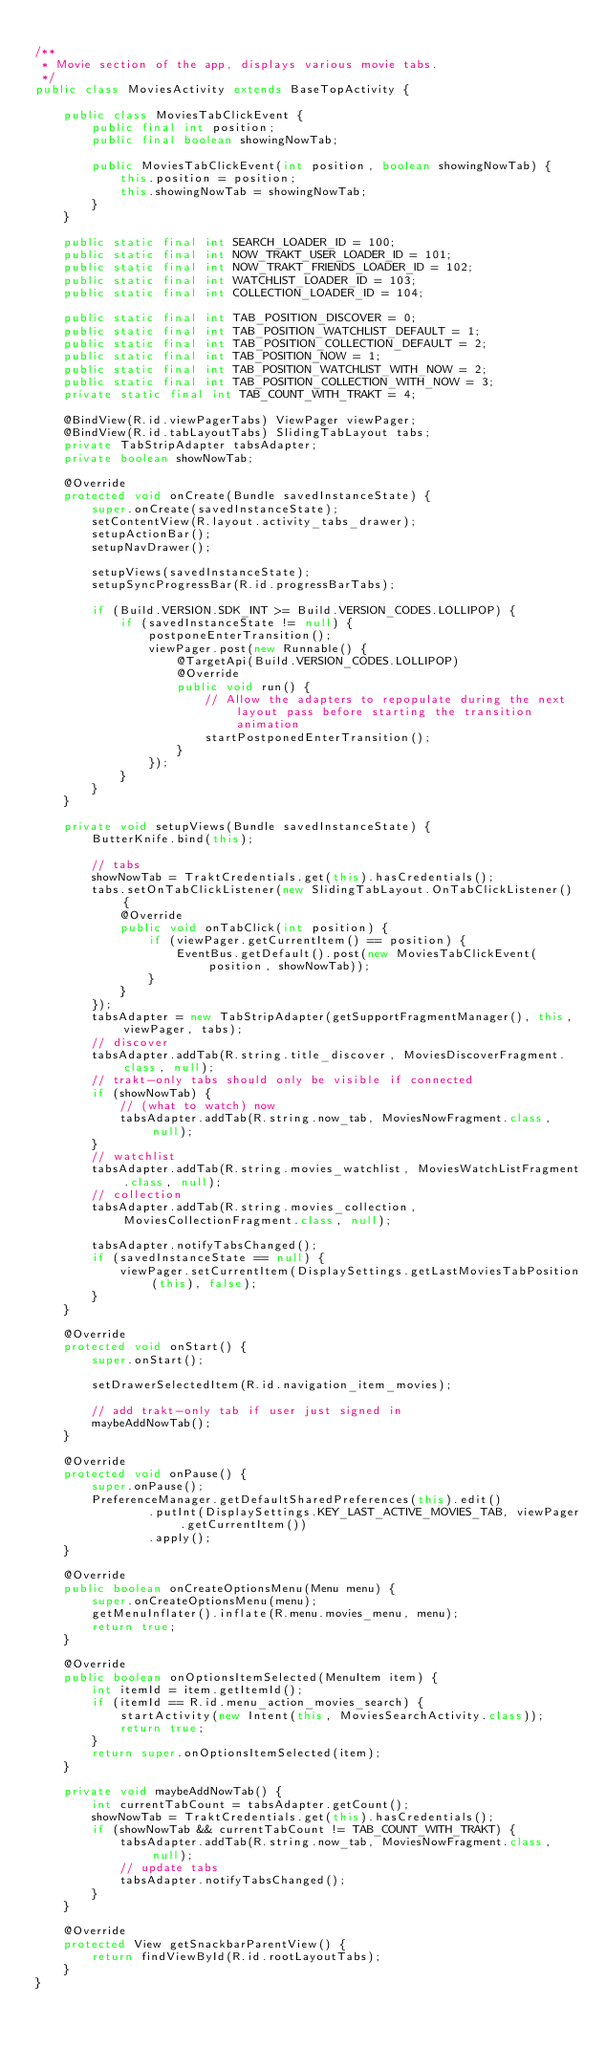<code> <loc_0><loc_0><loc_500><loc_500><_Java_>
/**
 * Movie section of the app, displays various movie tabs.
 */
public class MoviesActivity extends BaseTopActivity {

    public class MoviesTabClickEvent {
        public final int position;
        public final boolean showingNowTab;

        public MoviesTabClickEvent(int position, boolean showingNowTab) {
            this.position = position;
            this.showingNowTab = showingNowTab;
        }
    }

    public static final int SEARCH_LOADER_ID = 100;
    public static final int NOW_TRAKT_USER_LOADER_ID = 101;
    public static final int NOW_TRAKT_FRIENDS_LOADER_ID = 102;
    public static final int WATCHLIST_LOADER_ID = 103;
    public static final int COLLECTION_LOADER_ID = 104;

    public static final int TAB_POSITION_DISCOVER = 0;
    public static final int TAB_POSITION_WATCHLIST_DEFAULT = 1;
    public static final int TAB_POSITION_COLLECTION_DEFAULT = 2;
    public static final int TAB_POSITION_NOW = 1;
    public static final int TAB_POSITION_WATCHLIST_WITH_NOW = 2;
    public static final int TAB_POSITION_COLLECTION_WITH_NOW = 3;
    private static final int TAB_COUNT_WITH_TRAKT = 4;

    @BindView(R.id.viewPagerTabs) ViewPager viewPager;
    @BindView(R.id.tabLayoutTabs) SlidingTabLayout tabs;
    private TabStripAdapter tabsAdapter;
    private boolean showNowTab;

    @Override
    protected void onCreate(Bundle savedInstanceState) {
        super.onCreate(savedInstanceState);
        setContentView(R.layout.activity_tabs_drawer);
        setupActionBar();
        setupNavDrawer();

        setupViews(savedInstanceState);
        setupSyncProgressBar(R.id.progressBarTabs);

        if (Build.VERSION.SDK_INT >= Build.VERSION_CODES.LOLLIPOP) {
            if (savedInstanceState != null) {
                postponeEnterTransition();
                viewPager.post(new Runnable() {
                    @TargetApi(Build.VERSION_CODES.LOLLIPOP)
                    @Override
                    public void run() {
                        // Allow the adapters to repopulate during the next layout pass before starting the transition animation
                        startPostponedEnterTransition();
                    }
                });
            }
        }
    }

    private void setupViews(Bundle savedInstanceState) {
        ButterKnife.bind(this);

        // tabs
        showNowTab = TraktCredentials.get(this).hasCredentials();
        tabs.setOnTabClickListener(new SlidingTabLayout.OnTabClickListener() {
            @Override
            public void onTabClick(int position) {
                if (viewPager.getCurrentItem() == position) {
                    EventBus.getDefault().post(new MoviesTabClickEvent(position, showNowTab));
                }
            }
        });
        tabsAdapter = new TabStripAdapter(getSupportFragmentManager(), this, viewPager, tabs);
        // discover
        tabsAdapter.addTab(R.string.title_discover, MoviesDiscoverFragment.class, null);
        // trakt-only tabs should only be visible if connected
        if (showNowTab) {
            // (what to watch) now
            tabsAdapter.addTab(R.string.now_tab, MoviesNowFragment.class, null);
        }
        // watchlist
        tabsAdapter.addTab(R.string.movies_watchlist, MoviesWatchListFragment.class, null);
        // collection
        tabsAdapter.addTab(R.string.movies_collection, MoviesCollectionFragment.class, null);

        tabsAdapter.notifyTabsChanged();
        if (savedInstanceState == null) {
            viewPager.setCurrentItem(DisplaySettings.getLastMoviesTabPosition(this), false);
        }
    }

    @Override
    protected void onStart() {
        super.onStart();

        setDrawerSelectedItem(R.id.navigation_item_movies);

        // add trakt-only tab if user just signed in
        maybeAddNowTab();
    }

    @Override
    protected void onPause() {
        super.onPause();
        PreferenceManager.getDefaultSharedPreferences(this).edit()
                .putInt(DisplaySettings.KEY_LAST_ACTIVE_MOVIES_TAB, viewPager.getCurrentItem())
                .apply();
    }

    @Override
    public boolean onCreateOptionsMenu(Menu menu) {
        super.onCreateOptionsMenu(menu);
        getMenuInflater().inflate(R.menu.movies_menu, menu);
        return true;
    }

    @Override
    public boolean onOptionsItemSelected(MenuItem item) {
        int itemId = item.getItemId();
        if (itemId == R.id.menu_action_movies_search) {
            startActivity(new Intent(this, MoviesSearchActivity.class));
            return true;
        }
        return super.onOptionsItemSelected(item);
    }

    private void maybeAddNowTab() {
        int currentTabCount = tabsAdapter.getCount();
        showNowTab = TraktCredentials.get(this).hasCredentials();
        if (showNowTab && currentTabCount != TAB_COUNT_WITH_TRAKT) {
            tabsAdapter.addTab(R.string.now_tab, MoviesNowFragment.class, null);
            // update tabs
            tabsAdapter.notifyTabsChanged();
        }
    }

    @Override
    protected View getSnackbarParentView() {
        return findViewById(R.id.rootLayoutTabs);
    }
}
</code> 